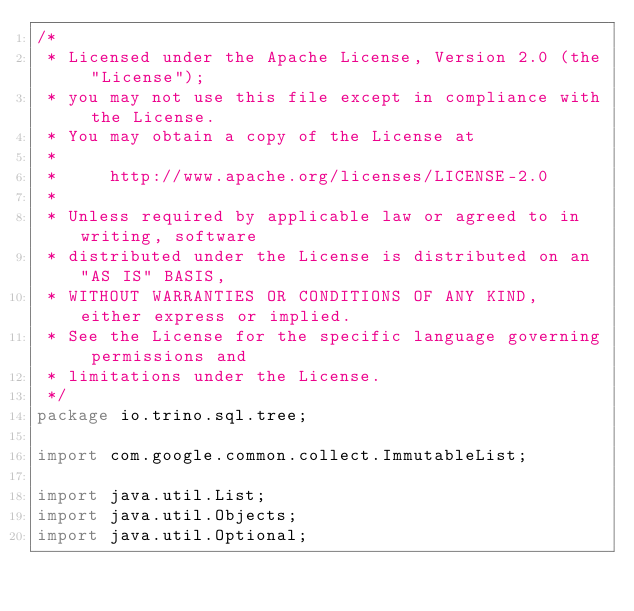<code> <loc_0><loc_0><loc_500><loc_500><_Java_>/*
 * Licensed under the Apache License, Version 2.0 (the "License");
 * you may not use this file except in compliance with the License.
 * You may obtain a copy of the License at
 *
 *     http://www.apache.org/licenses/LICENSE-2.0
 *
 * Unless required by applicable law or agreed to in writing, software
 * distributed under the License is distributed on an "AS IS" BASIS,
 * WITHOUT WARRANTIES OR CONDITIONS OF ANY KIND, either express or implied.
 * See the License for the specific language governing permissions and
 * limitations under the License.
 */
package io.trino.sql.tree;

import com.google.common.collect.ImmutableList;

import java.util.List;
import java.util.Objects;
import java.util.Optional;
</code> 